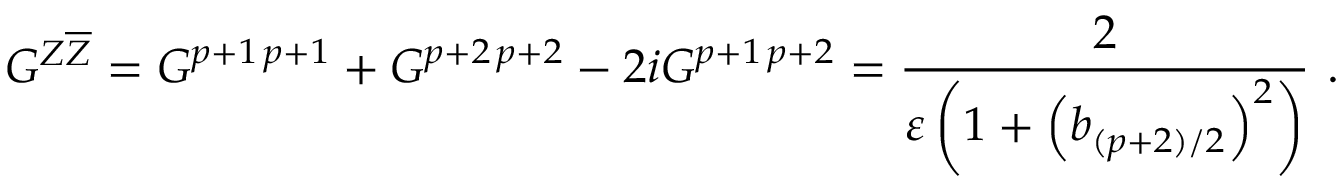Convert formula to latex. <formula><loc_0><loc_0><loc_500><loc_500>G ^ { Z \overline { Z } } = G ^ { p + 1 \, p + 1 } + G ^ { p + 2 \, p + 2 } - 2 i G ^ { p + 1 \, p + 2 } = \frac { 2 } { \varepsilon \left ( 1 + \left ( b _ { ( p + 2 ) / 2 } \right ) ^ { 2 } \right ) } .</formula> 